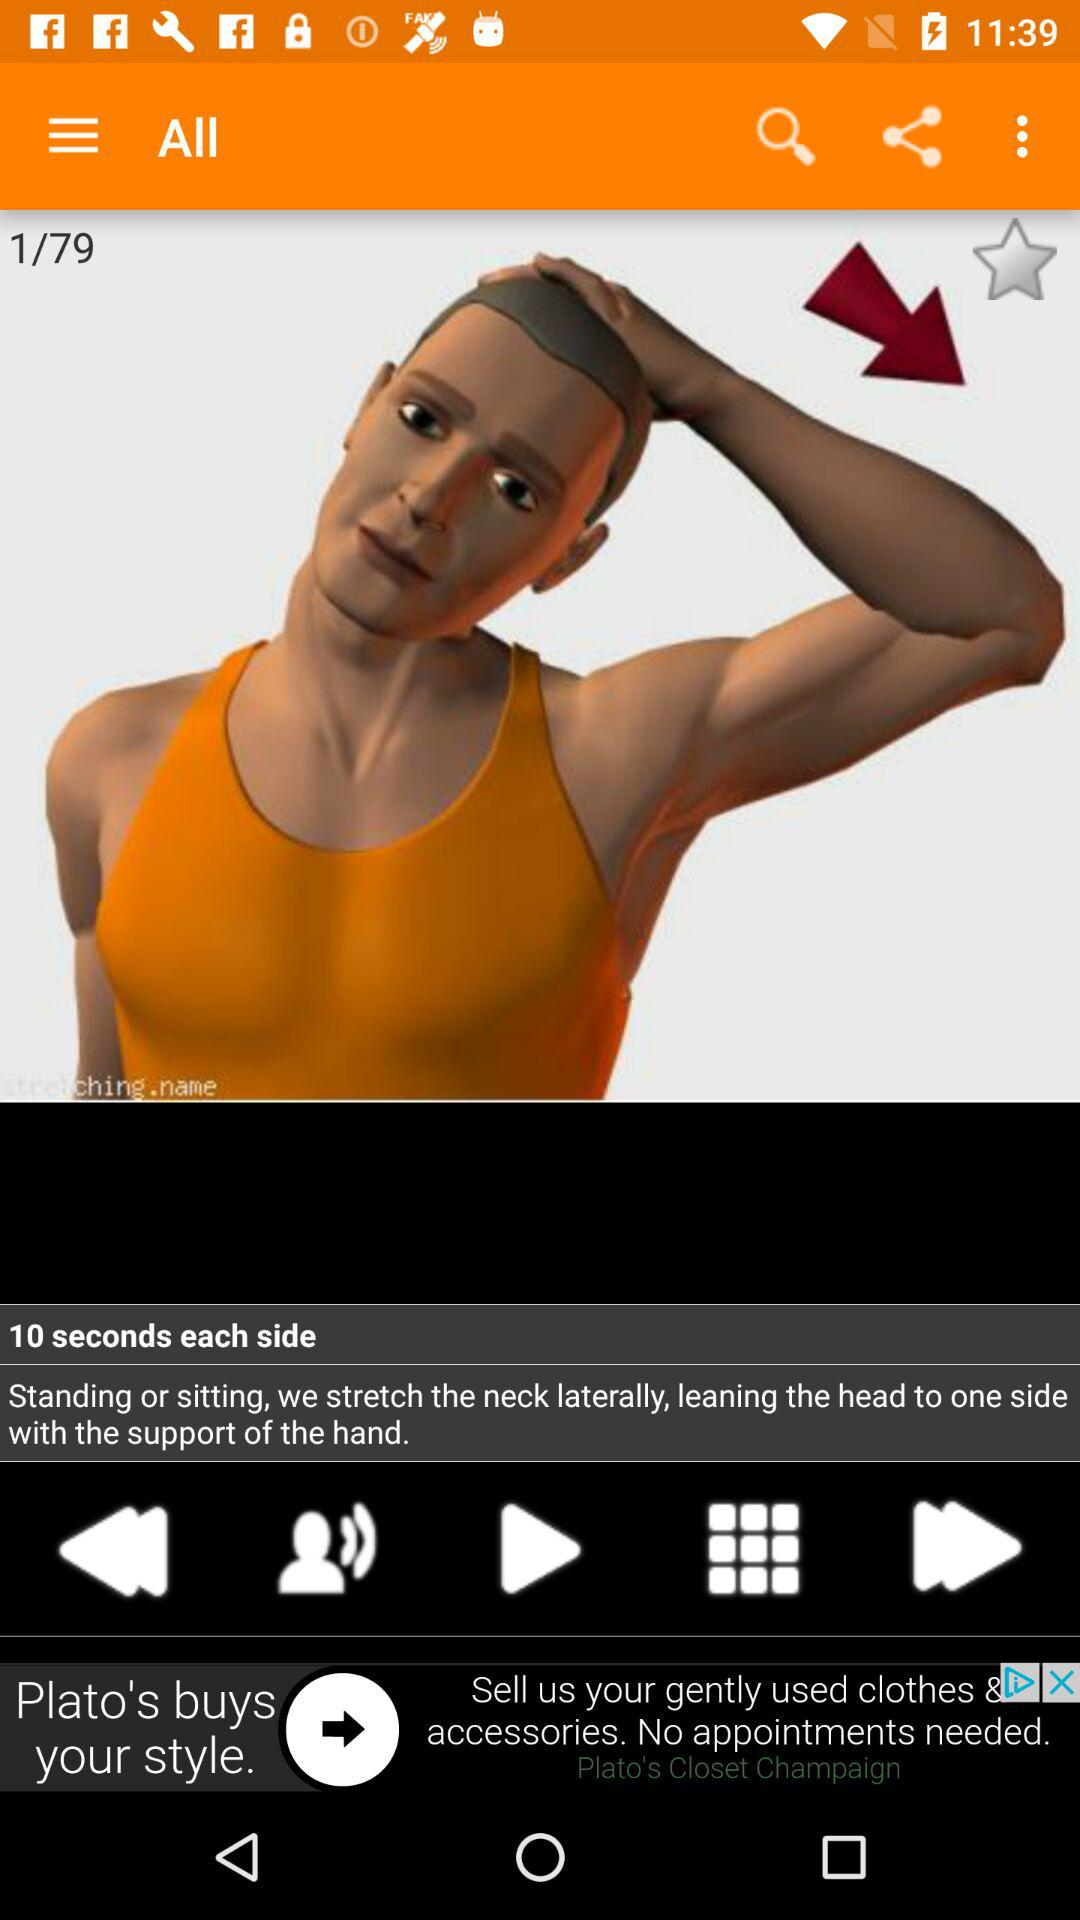How many sets are available in exercise?
When the provided information is insufficient, respond with <no answer>. <no answer> 